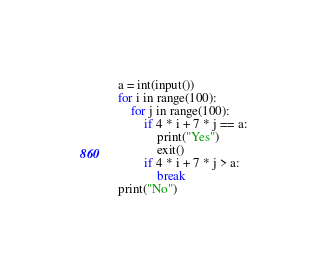Convert code to text. <code><loc_0><loc_0><loc_500><loc_500><_Python_>a = int(input())
for i in range(100):
    for j in range(100):
        if 4 * i + 7 * j == a:
            print("Yes")
            exit()
        if 4 * i + 7 * j > a:
            break
print("No")
</code> 